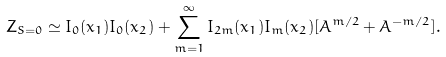<formula> <loc_0><loc_0><loc_500><loc_500>Z _ { S = 0 } \simeq I _ { 0 } ( x _ { 1 } ) I _ { 0 } ( x _ { 2 } ) + \sum _ { m = 1 } ^ { \infty } I _ { 2 m } ( x _ { 1 } ) I _ { m } ( x _ { 2 } ) [ A ^ { m / 2 } + A ^ { - m / 2 } ] .</formula> 